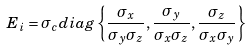<formula> <loc_0><loc_0><loc_500><loc_500>E _ { i } = \sigma _ { c } d i a g \left \{ \frac { \sigma _ { x } } { \sigma _ { y } \sigma _ { z } } , \frac { \sigma _ { y } } { \sigma _ { x } \sigma _ { z } } , \frac { \sigma _ { z } } { \sigma _ { x } \sigma _ { y } } \right \}</formula> 